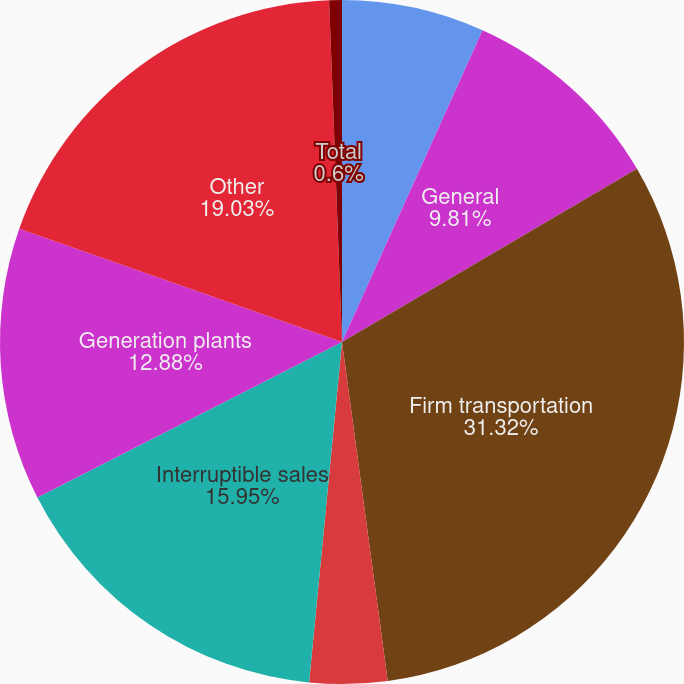<chart> <loc_0><loc_0><loc_500><loc_500><pie_chart><fcel>Residential<fcel>General<fcel>Firm transportation<fcel>Total firm sales and<fcel>Interruptible sales<fcel>Generation plants<fcel>Other<fcel>Total<nl><fcel>6.74%<fcel>9.81%<fcel>31.31%<fcel>3.67%<fcel>15.95%<fcel>12.88%<fcel>19.03%<fcel>0.6%<nl></chart> 